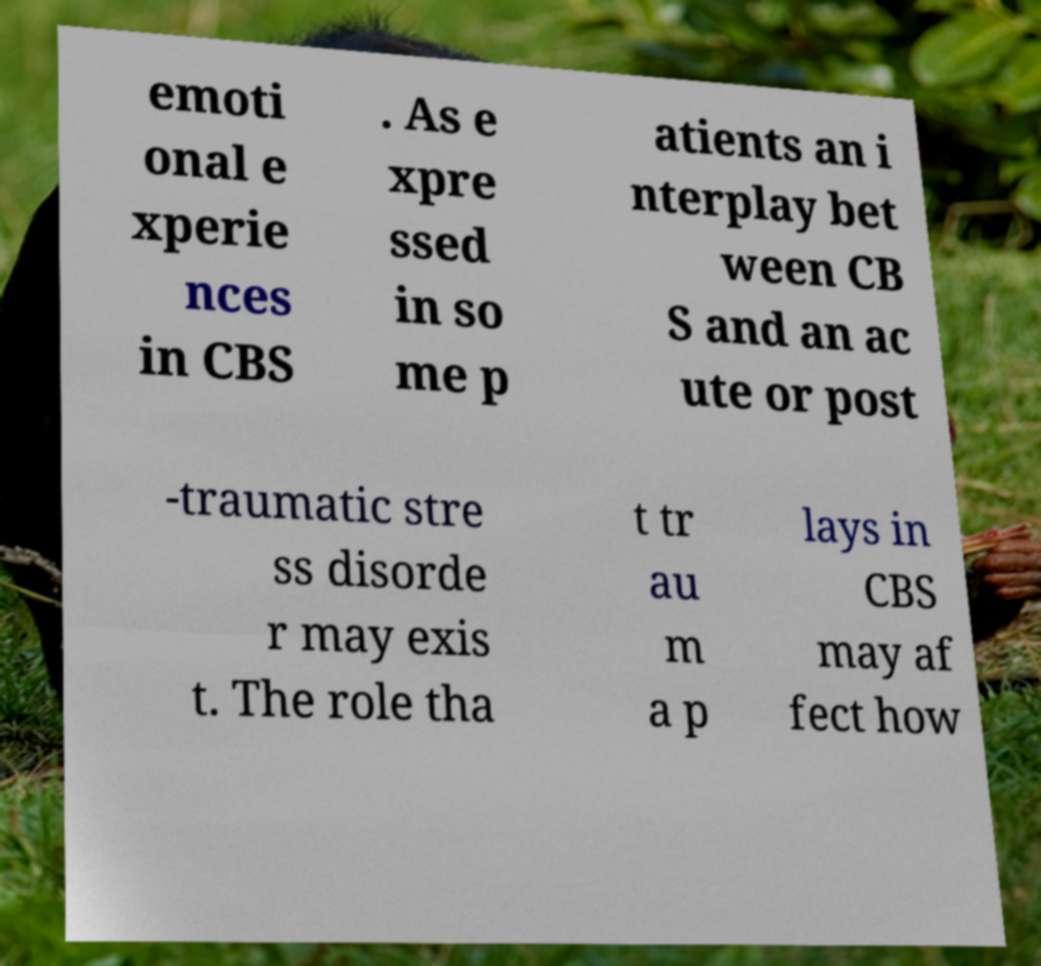What messages or text are displayed in this image? I need them in a readable, typed format. emoti onal e xperie nces in CBS . As e xpre ssed in so me p atients an i nterplay bet ween CB S and an ac ute or post -traumatic stre ss disorde r may exis t. The role tha t tr au m a p lays in CBS may af fect how 